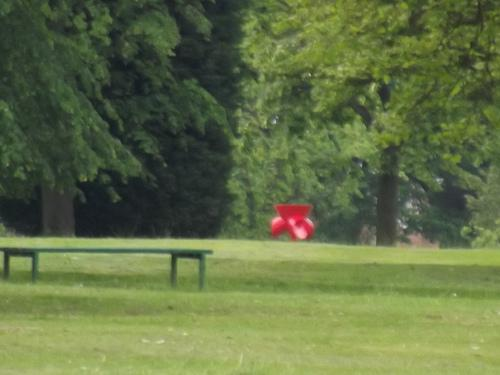Question: where is this scene located?
Choices:
A. Park.
B. House.
C. City square.
D. School.
Answer with the letter. Answer: A Question: what is on the ground at this park?
Choices:
A. Grass.
B. Cement.
C. Tennis court.
D. Plants.
Answer with the letter. Answer: A Question: how many people are in the photo?
Choices:
A. One.
B. Three.
C. Two.
D. None.
Answer with the letter. Answer: D Question: where is this taking place?
Choices:
A. Dance hall.
B. At a park.
C. Near the field.
D. By the station.
Answer with the letter. Answer: B 